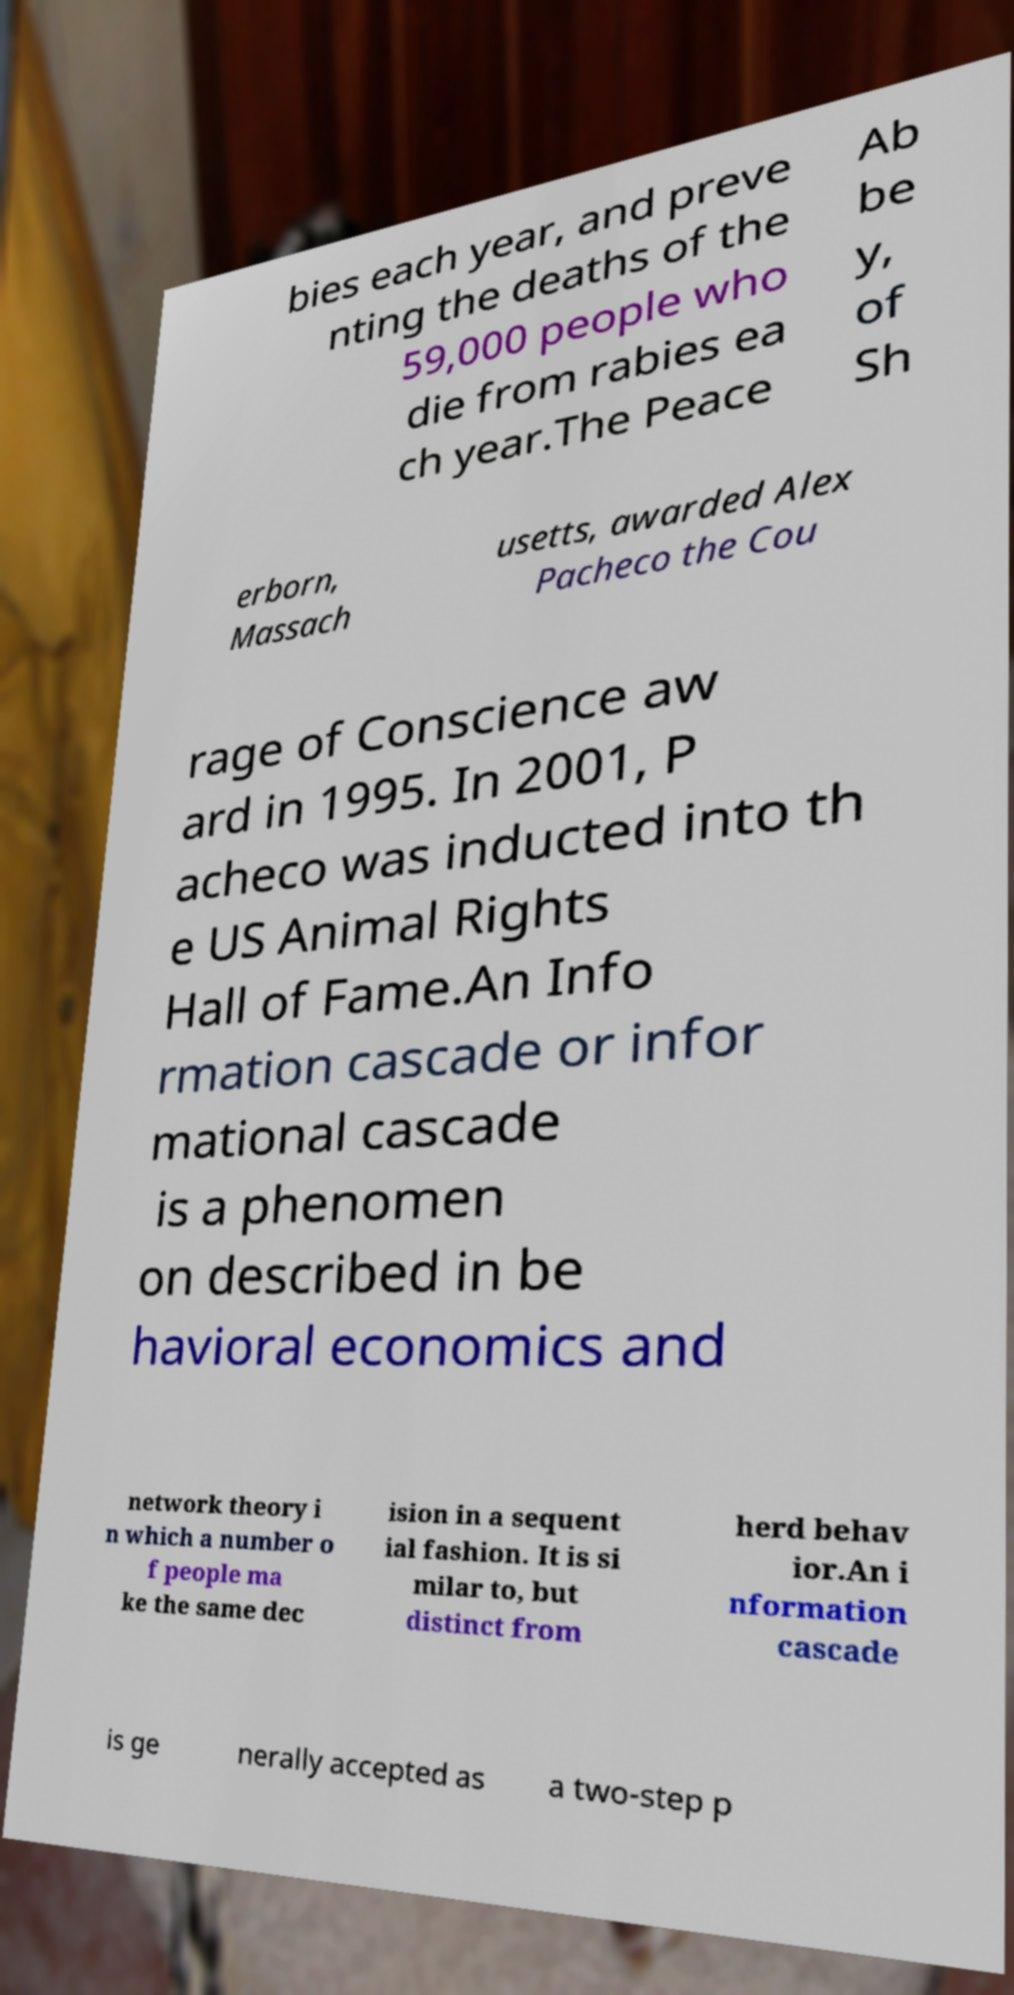I need the written content from this picture converted into text. Can you do that? bies each year, and preve nting the deaths of the 59,000 people who die from rabies ea ch year.The Peace Ab be y, of Sh erborn, Massach usetts, awarded Alex Pacheco the Cou rage of Conscience aw ard in 1995. In 2001, P acheco was inducted into th e US Animal Rights Hall of Fame.An Info rmation cascade or infor mational cascade is a phenomen on described in be havioral economics and network theory i n which a number o f people ma ke the same dec ision in a sequent ial fashion. It is si milar to, but distinct from herd behav ior.An i nformation cascade is ge nerally accepted as a two-step p 